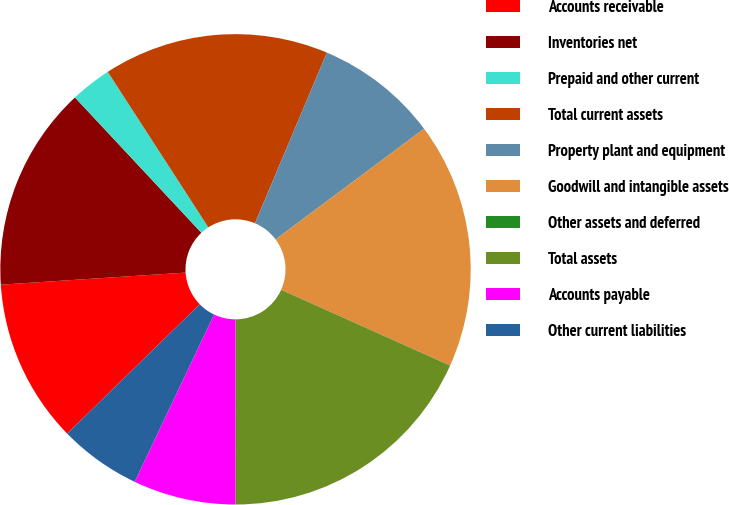<chart> <loc_0><loc_0><loc_500><loc_500><pie_chart><fcel>Accounts receivable<fcel>Inventories net<fcel>Prepaid and other current<fcel>Total current assets<fcel>Property plant and equipment<fcel>Goodwill and intangible assets<fcel>Other assets and deferred<fcel>Total assets<fcel>Accounts payable<fcel>Other current liabilities<nl><fcel>11.27%<fcel>14.08%<fcel>2.82%<fcel>15.49%<fcel>8.45%<fcel>16.9%<fcel>0.01%<fcel>18.3%<fcel>7.04%<fcel>5.64%<nl></chart> 